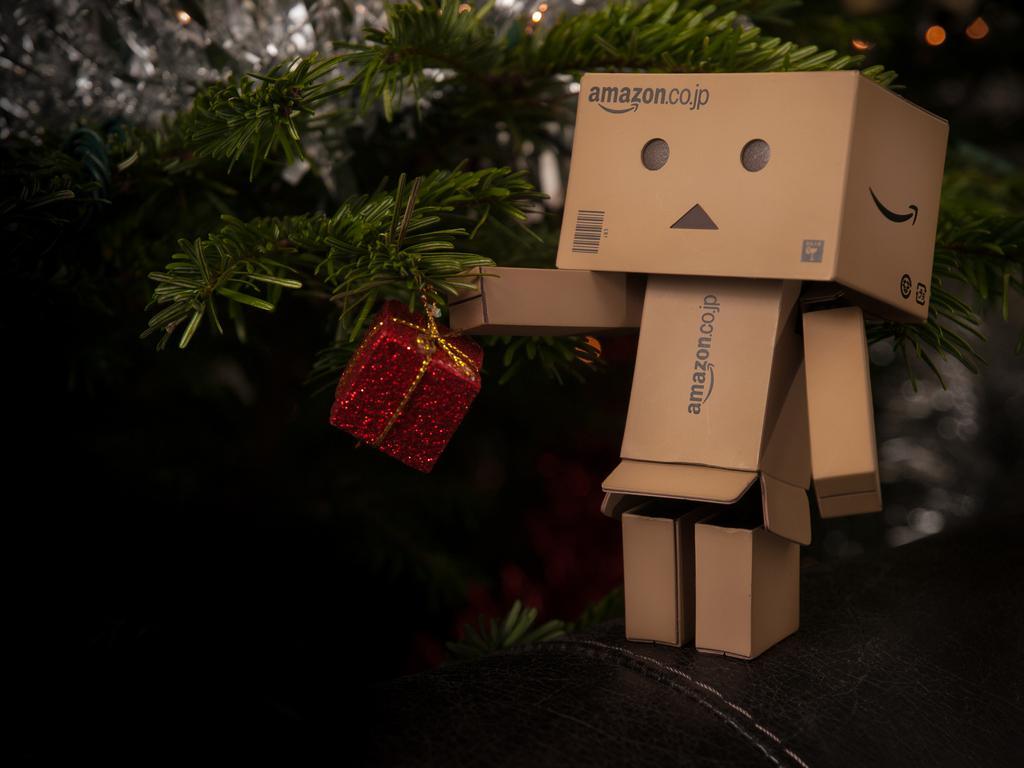Please provide a concise description of this image. In this picture there is a cardboard toy on the right side of the image and there is a gift box in the center of the image and there are plants in the image. 